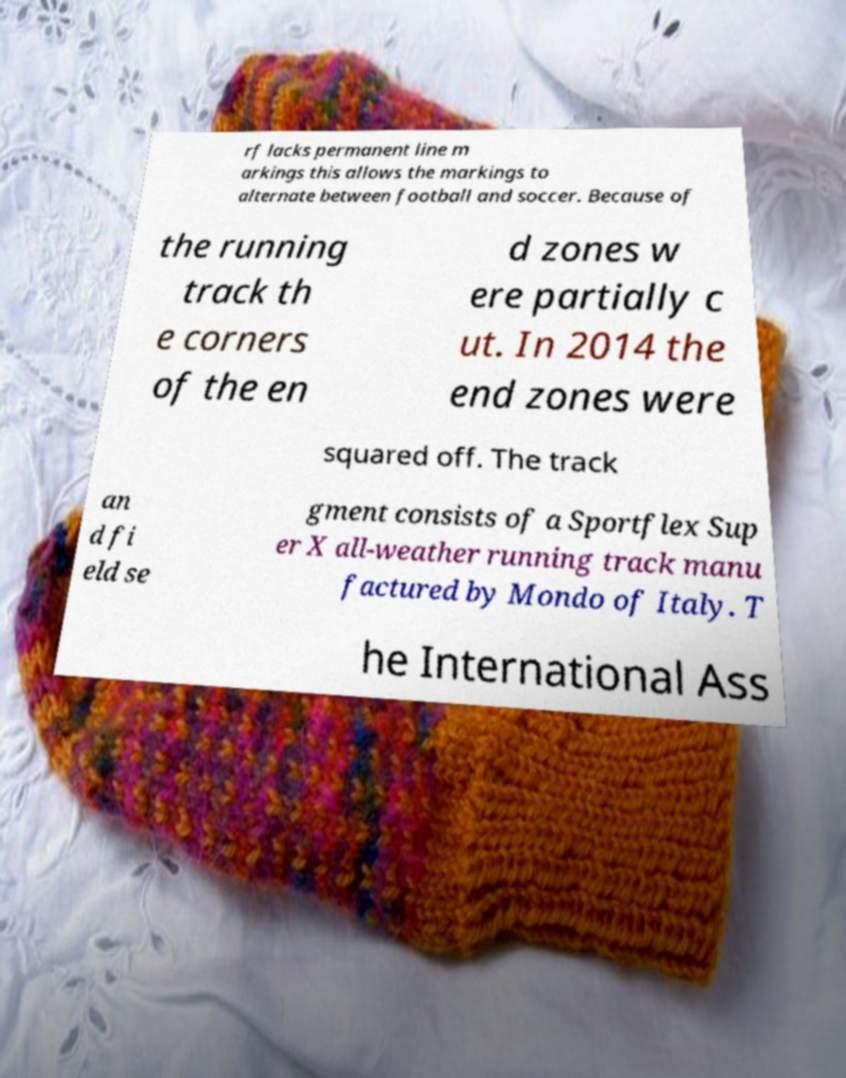For documentation purposes, I need the text within this image transcribed. Could you provide that? rf lacks permanent line m arkings this allows the markings to alternate between football and soccer. Because of the running track th e corners of the en d zones w ere partially c ut. In 2014 the end zones were squared off. The track an d fi eld se gment consists of a Sportflex Sup er X all-weather running track manu factured by Mondo of Italy. T he International Ass 